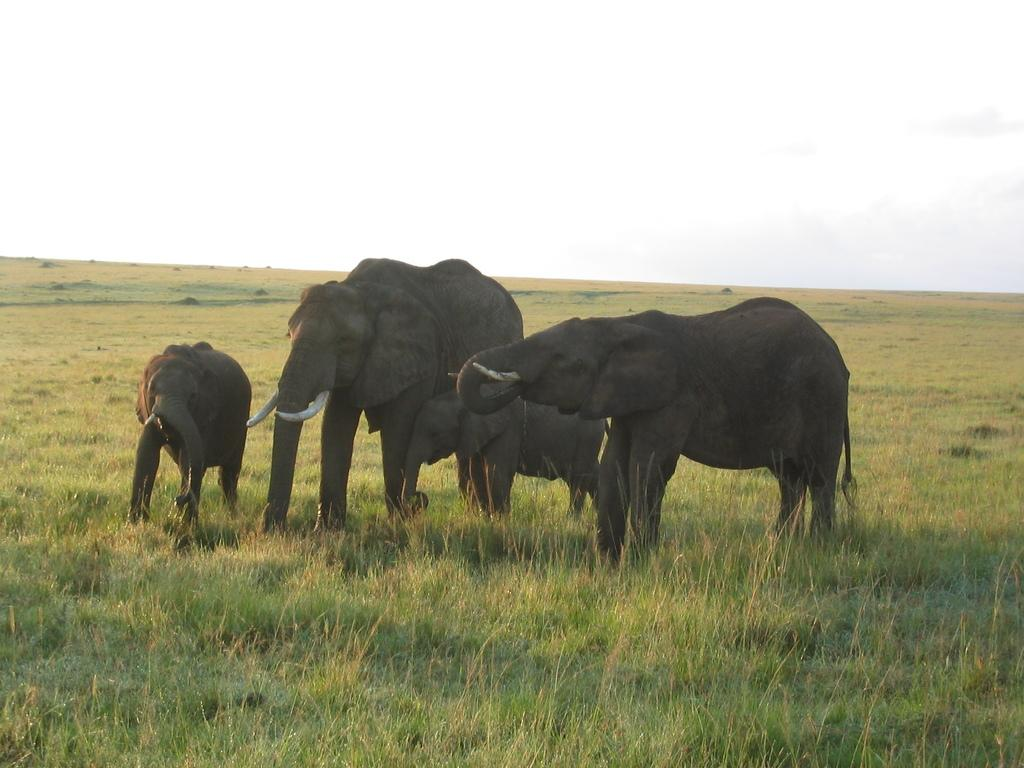How many elephants are in the image? There are four elephants in the image. What type of vegetation is at the bottom of the image? There is green grass at the bottom of the image. What can be seen in the background of the image? There is a mountain visible in the background of the image. What is visible at the top of the image? The sky is visible at the top of the image. What can be observed in the sky? Clouds are present in the sky. What type of health advice can be seen on the bed in the image? There is no bed present in the image, and therefore no health advice can be observed. 